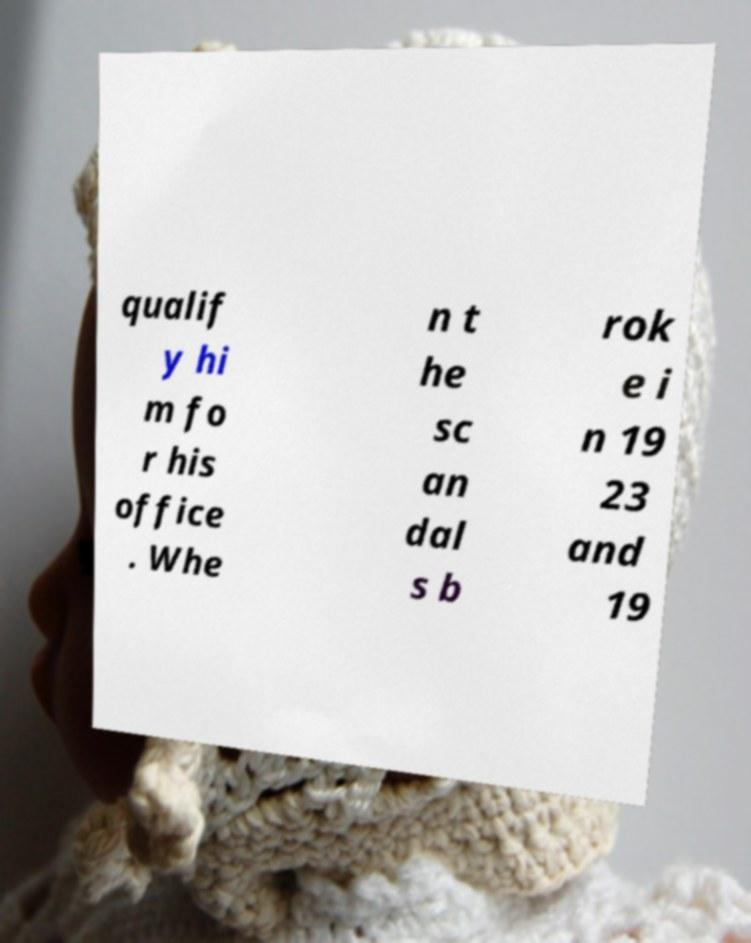Please read and relay the text visible in this image. What does it say? qualif y hi m fo r his office . Whe n t he sc an dal s b rok e i n 19 23 and 19 